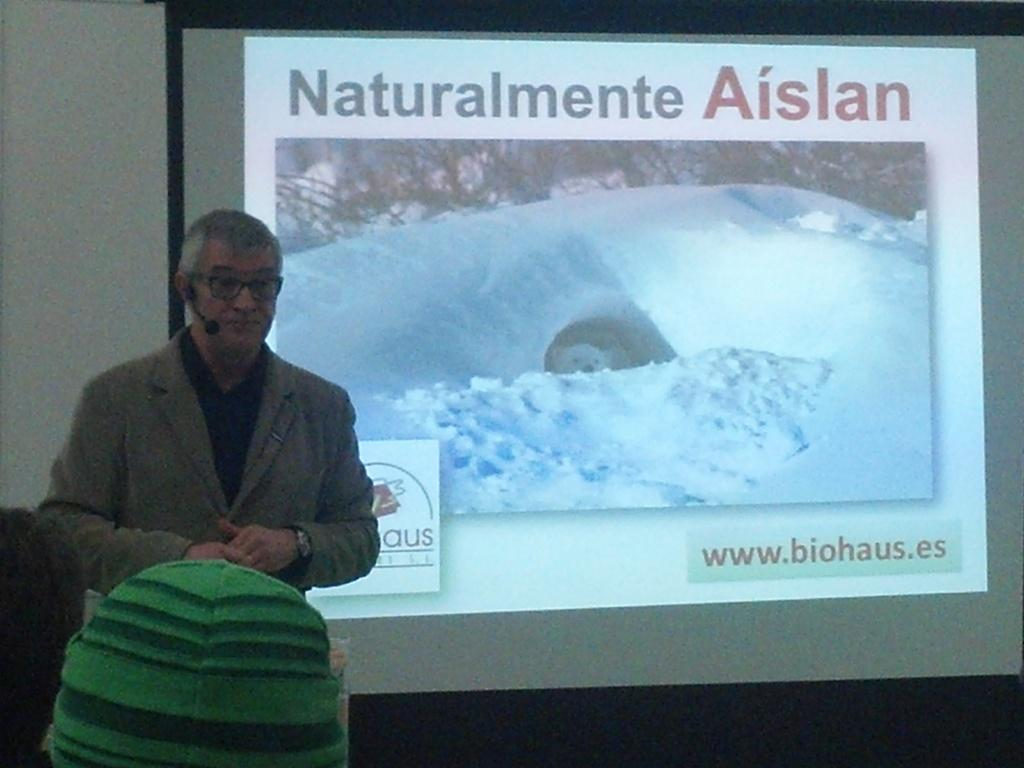What type of structure can be seen in the image? There is a wall in the image. What device is present in the image? There is a screen in the image. Can you describe the person in the image? There is a man standing in the image. What type of fear can be seen on the man's face in the image? There is no indication of fear on the man's face in the image. What type of connection is the man making with the screen in the image? The image does not show the man interacting with the screen, so it is not possible to determine the type of connection he might be making. 